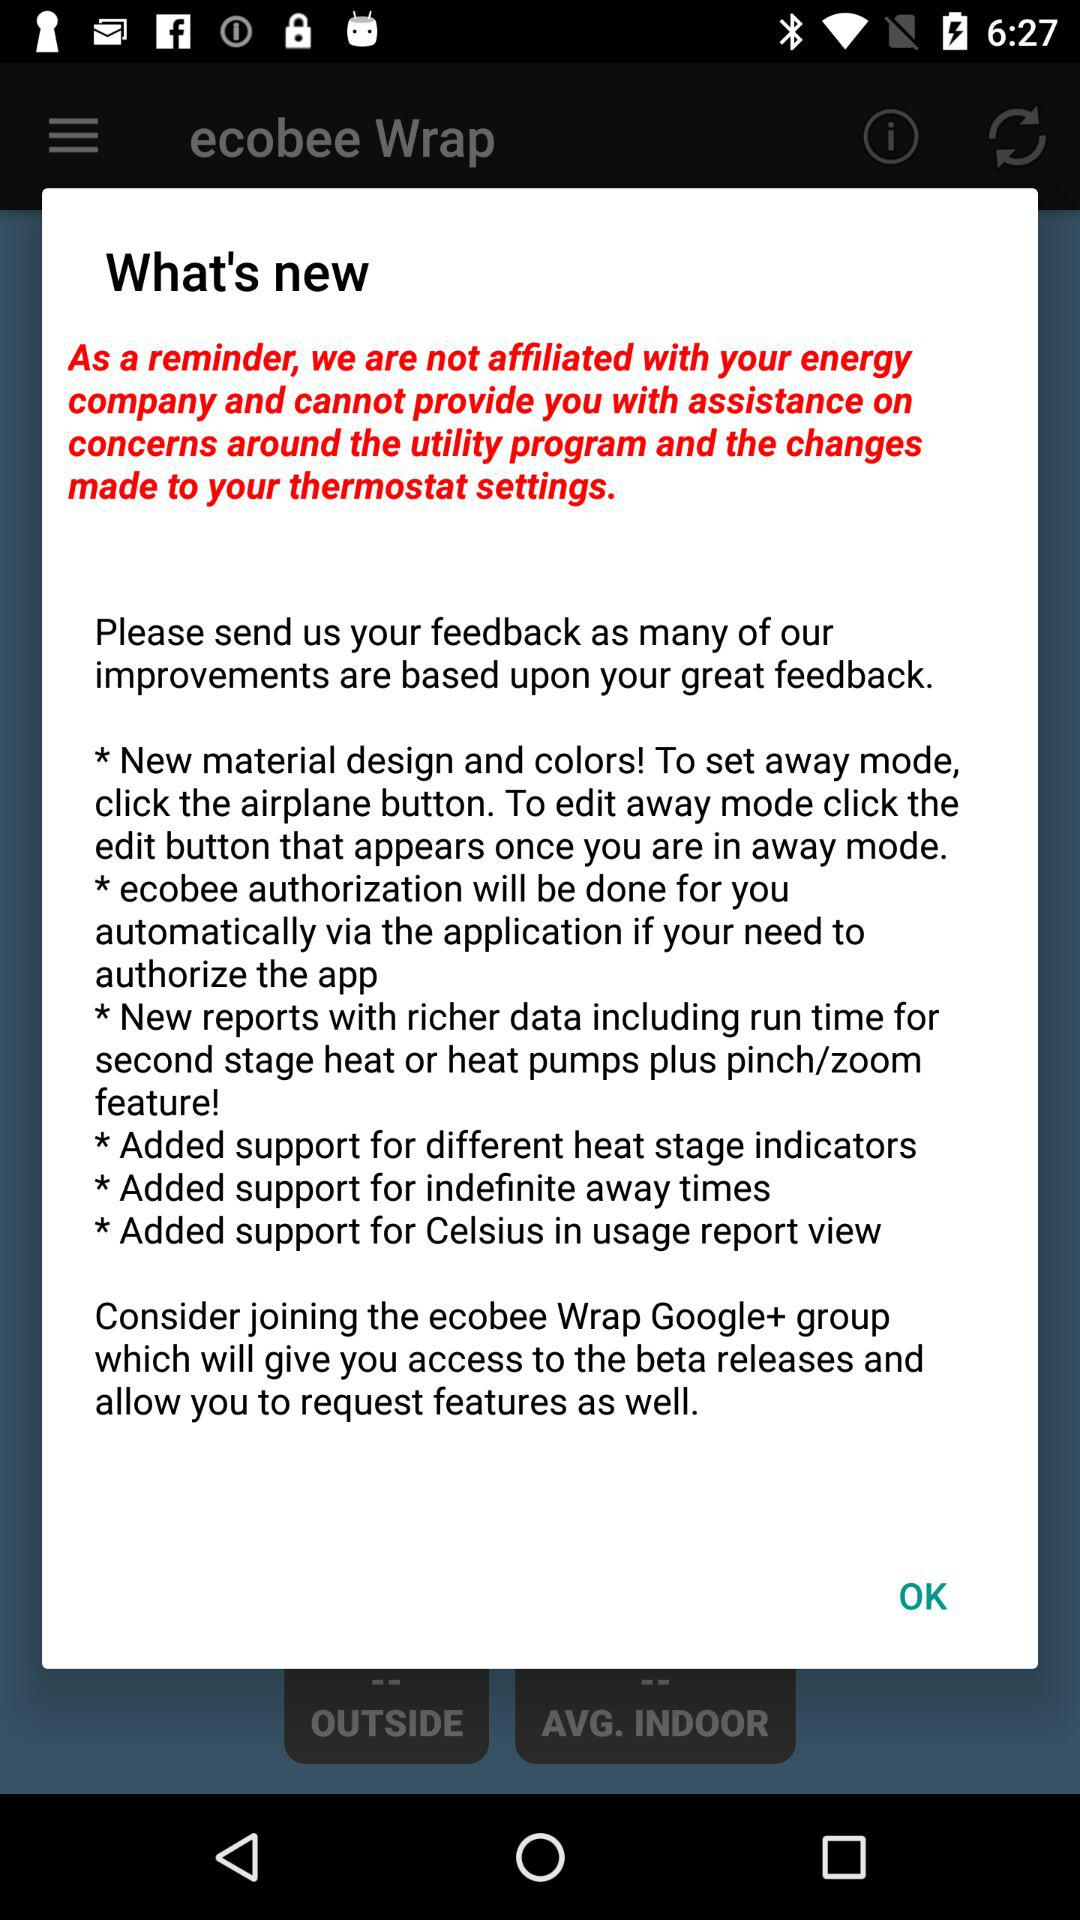How many new features are related to reports?
Answer the question using a single word or phrase. 2 